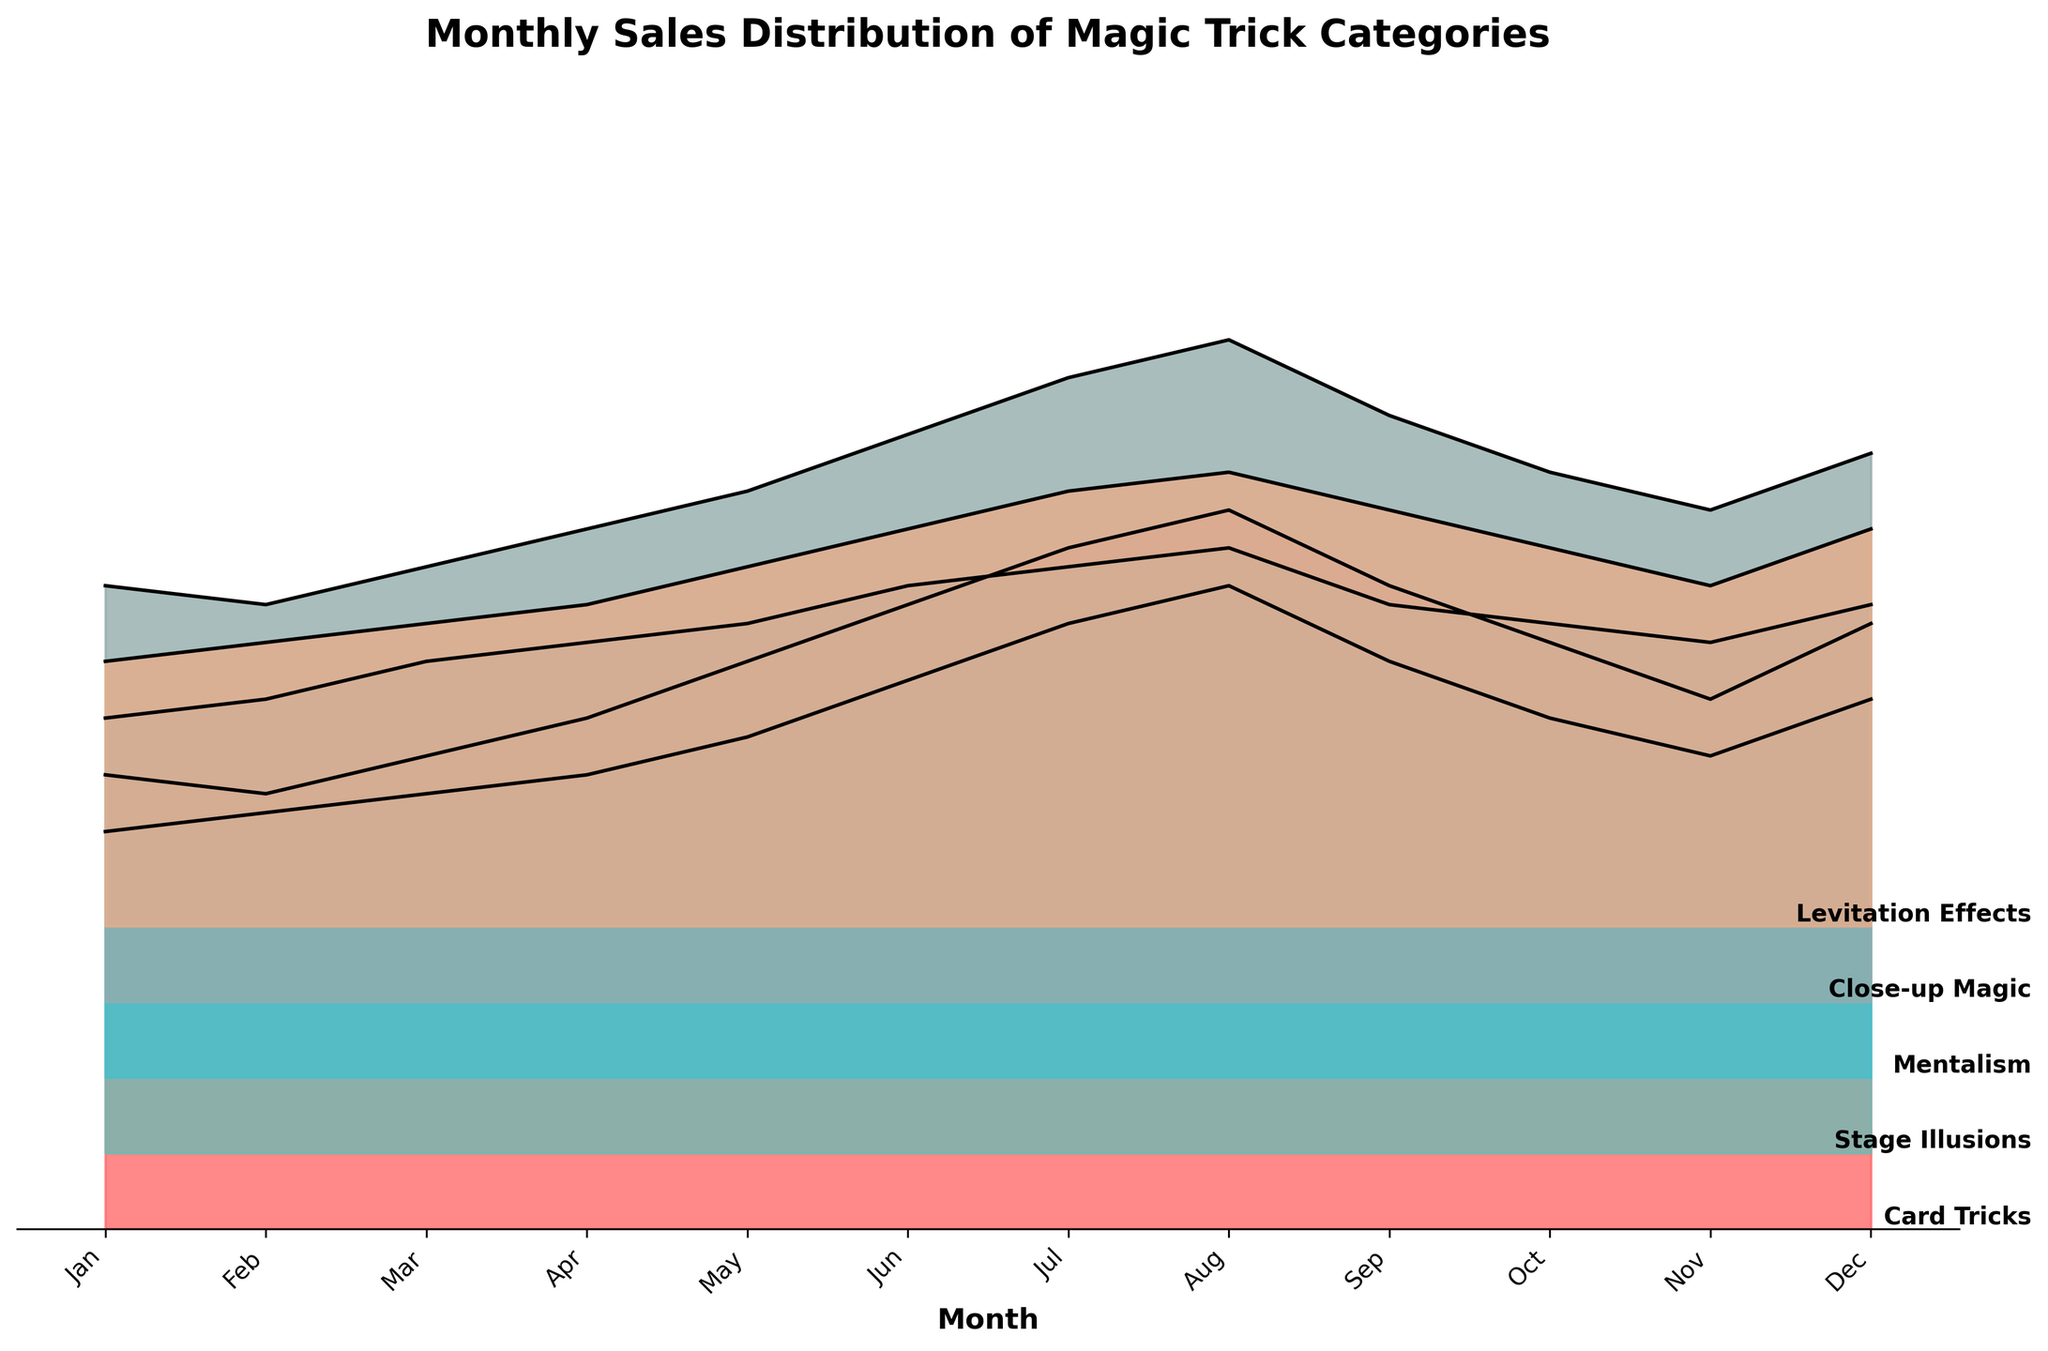What is the highest sales month for Card Tricks? The plot shows the monthly sales data for different categories, with Card Tricks as one of the categories. By observing the line for Card Tricks, we see the highest peak in August.
Answer: August Which month has the lowest sales for Levitation Effects? The plot shows the monthly sales distribution, and Levitation Effects' line can be identified by its color. The lowest point on this line occurs in January.
Answer: January Compare the sales of Stage Illusions and Mentalism in June. Which category had higher sales? By looking at the y-values in June for both Stage Illusions and Mentalism, we see that Stage Illusions has a value of 125 and Mentalism a value of 130. Hence, Mentalism had higher sales.
Answer: Mentalism What is the general trend of Close-up Magic sales throughout the year? Examining the plot line for Close-up Magic, we notice it steadily increases from January up until August, then sees a decline towards December.
Answer: Increase till August, then decrease Calculate the average sales of Levitation Effects in the first half of the year (January to June). Summing up the sales in the first six months: (70+75+80+85+95+105) = 510. The average is 510/6.
Answer: 85 Which category shows the most consistent sales throughout the year? By analyzing the fluctuation in the lines, Stage Illusions appears to have the smallest range between its highest and lowest values, indicating more consistent sales.
Answer: Stage Illusions In which month do Card Tricks and Stage Illusions sales intersect, if ever? The plot should show the approximate values of Card Tricks and Stage Illusions lines. Observing them, they appear to intersect in October.
Answer: October How do the sales of Card Tricks in July compare to those in September? Observing the plot for Card Tricks, the sales in July are at their highest point in the year, whereas in September the sales are slightly lower.
Answer: Higher in July than in September What is the difference in sales between Close-up Magic and Mentalism in December? Looking at values for December, Close-up Magic is at 145 and Mentalism at 125. The difference is 145 - 125.
Answer: 20 Which category had the largest increase in sales from January to June? Observing the difference between January and June values for each category, Card Tricks increased the most from 120 to 165, a difference of 45 units.
Answer: Card Tricks 